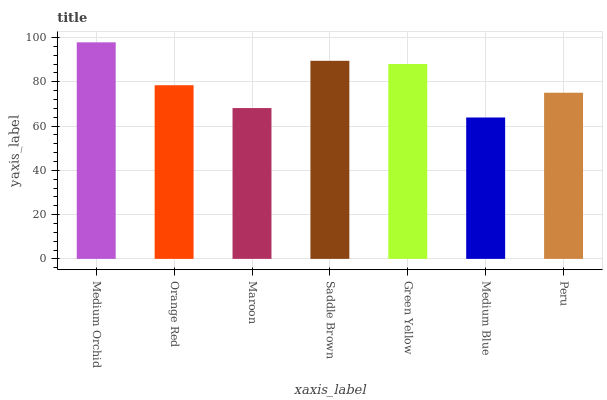Is Medium Blue the minimum?
Answer yes or no. Yes. Is Medium Orchid the maximum?
Answer yes or no. Yes. Is Orange Red the minimum?
Answer yes or no. No. Is Orange Red the maximum?
Answer yes or no. No. Is Medium Orchid greater than Orange Red?
Answer yes or no. Yes. Is Orange Red less than Medium Orchid?
Answer yes or no. Yes. Is Orange Red greater than Medium Orchid?
Answer yes or no. No. Is Medium Orchid less than Orange Red?
Answer yes or no. No. Is Orange Red the high median?
Answer yes or no. Yes. Is Orange Red the low median?
Answer yes or no. Yes. Is Medium Blue the high median?
Answer yes or no. No. Is Medium Blue the low median?
Answer yes or no. No. 